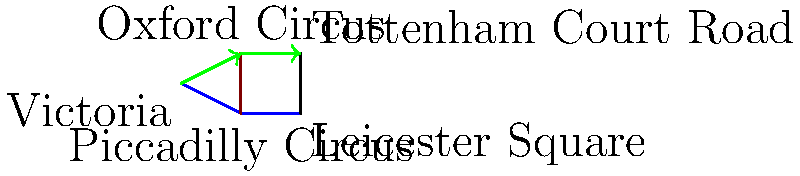You're planning a trip from Victoria station to Tottenham Court Road station using the London Underground. The journey can be represented by two vectors: $\vec{a}$ from Victoria to Oxford Circus, and $\vec{b}$ from Oxford Circus to Tottenham Court Road. If $\vec{a} = 2\hat{i} + \hat{j}$ and $\vec{b} = 2\hat{i}$, what is the magnitude of the resultant vector $\vec{r} = \vec{a} + \vec{b}$ representing your entire journey? Let's solve this step-by-step:

1) We are given two vectors:
   $\vec{a} = 2\hat{i} + \hat{j}$
   $\vec{b} = 2\hat{i}$

2) The resultant vector $\vec{r}$ is the sum of these vectors:
   $\vec{r} = \vec{a} + \vec{b}$

3) Let's add the vectors:
   $\vec{r} = (2\hat{i} + \hat{j}) + (2\hat{i})$
   $\vec{r} = 4\hat{i} + \hat{j}$

4) Now, to find the magnitude of $\vec{r}$, we use the Pythagorean theorem:
   $|\vec{r}| = \sqrt{(4)^2 + (1)^2}$

5) Simplify:
   $|\vec{r}| = \sqrt{16 + 1} = \sqrt{17}$

Therefore, the magnitude of the resultant vector $\vec{r}$ is $\sqrt{17}$ units.
Answer: $\sqrt{17}$ units 